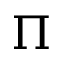<formula> <loc_0><loc_0><loc_500><loc_500>{ \Pi }</formula> 